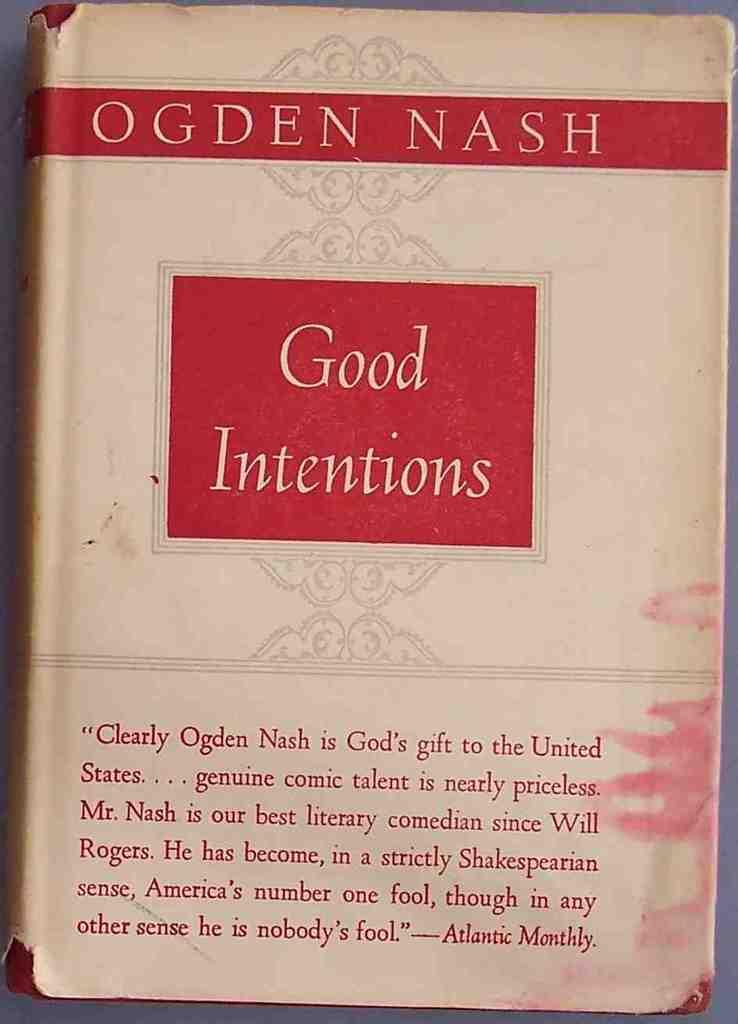<image>
Present a compact description of the photo's key features. Book cover called "Good Intentions" written by Ogden Nash. 